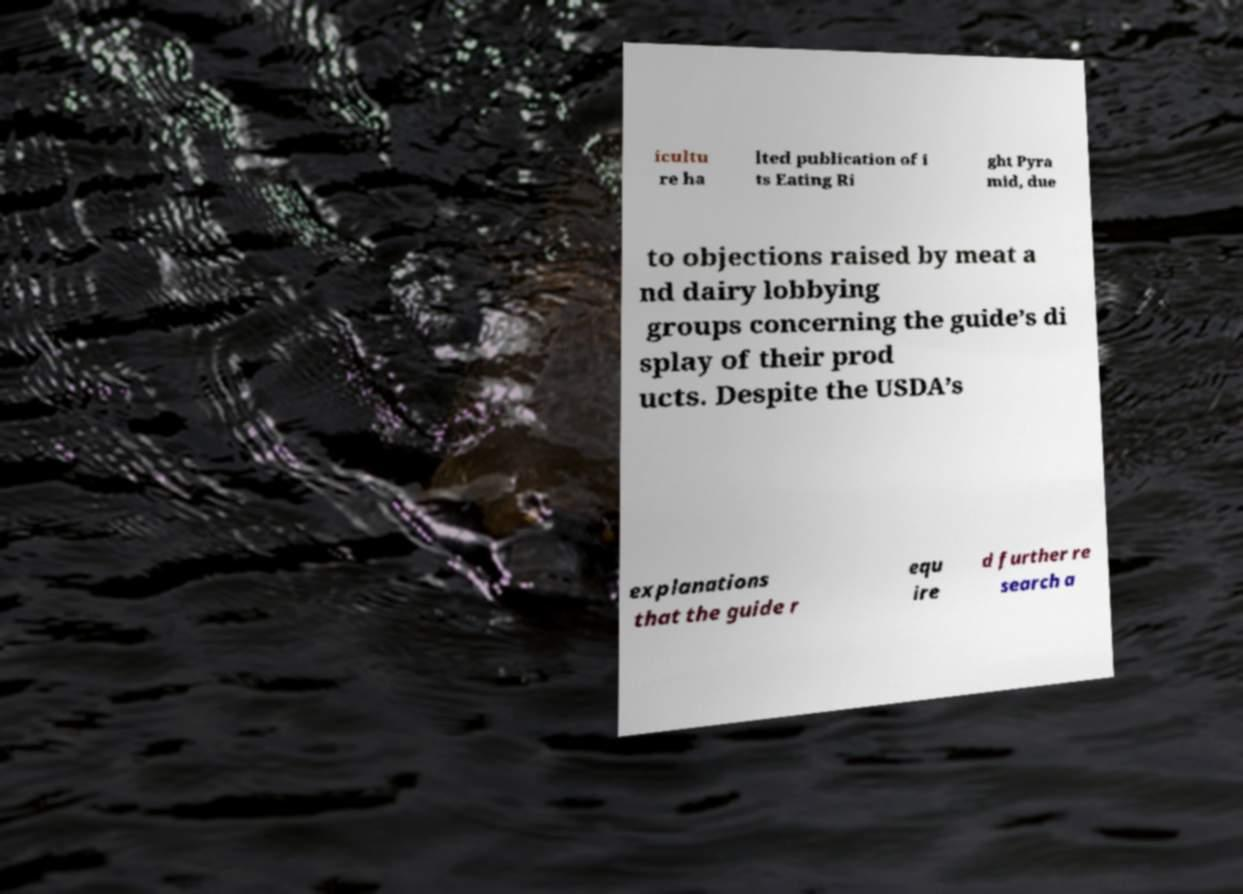Could you assist in decoding the text presented in this image and type it out clearly? icultu re ha lted publication of i ts Eating Ri ght Pyra mid, due to objections raised by meat a nd dairy lobbying groups concerning the guide’s di splay of their prod ucts. Despite the USDA’s explanations that the guide r equ ire d further re search a 